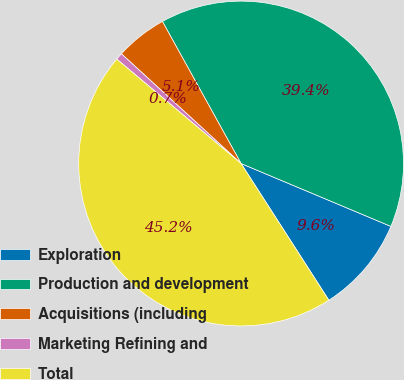Convert chart to OTSL. <chart><loc_0><loc_0><loc_500><loc_500><pie_chart><fcel>Exploration<fcel>Production and development<fcel>Acquisitions (including<fcel>Marketing Refining and<fcel>Total<nl><fcel>9.59%<fcel>39.37%<fcel>5.14%<fcel>0.69%<fcel>45.2%<nl></chart> 